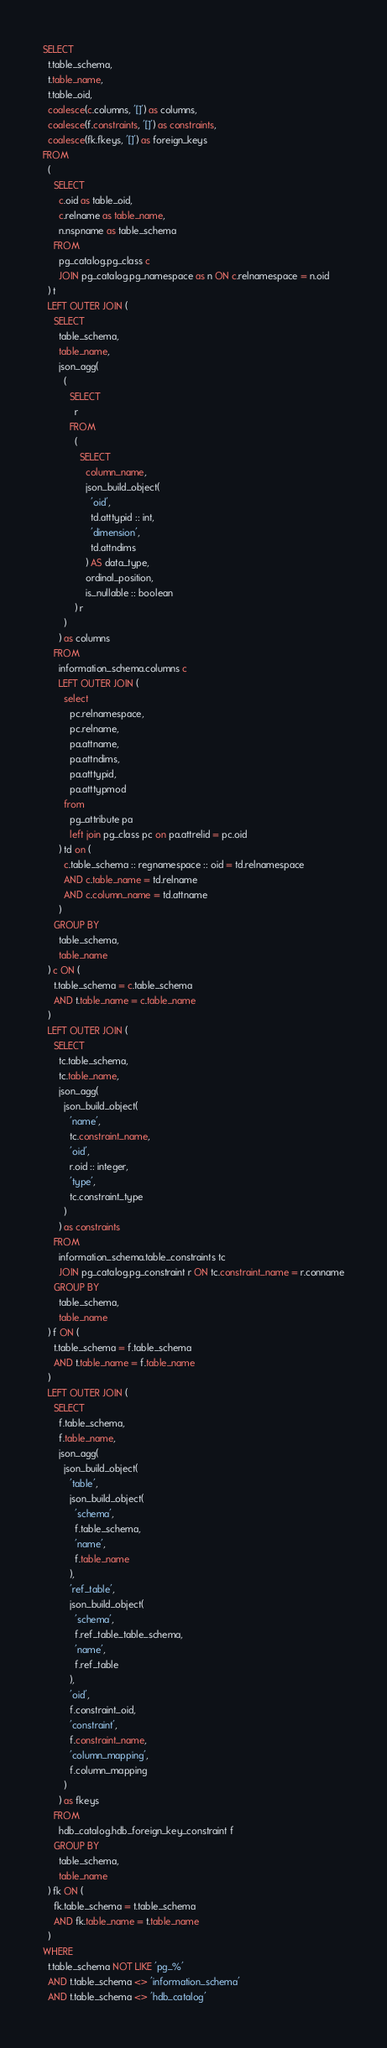<code> <loc_0><loc_0><loc_500><loc_500><_SQL_>SELECT
  t.table_schema,
  t.table_name,
  t.table_oid,
  coalesce(c.columns, '[]') as columns,
  coalesce(f.constraints, '[]') as constraints,
  coalesce(fk.fkeys, '[]') as foreign_keys
FROM
  (
    SELECT
      c.oid as table_oid,
      c.relname as table_name,
      n.nspname as table_schema
    FROM
      pg_catalog.pg_class c
      JOIN pg_catalog.pg_namespace as n ON c.relnamespace = n.oid
  ) t
  LEFT OUTER JOIN (
    SELECT
      table_schema,
      table_name,
      json_agg(
        (
          SELECT
            r
          FROM
            (
              SELECT
                column_name,
                json_build_object(
                  'oid',
                  td.atttypid :: int,
                  'dimension',
                  td.attndims
                ) AS data_type,
                ordinal_position,
                is_nullable :: boolean
            ) r
        )
      ) as columns
    FROM
      information_schema.columns c
      LEFT OUTER JOIN (
        select
          pc.relnamespace,
          pc.relname,
          pa.attname,
          pa.attndims,
          pa.atttypid,
          pa.atttypmod
        from
          pg_attribute pa
          left join pg_class pc on pa.attrelid = pc.oid
      ) td on (
        c.table_schema :: regnamespace :: oid = td.relnamespace
        AND c.table_name = td.relname
        AND c.column_name = td.attname
      )
    GROUP BY
      table_schema,
      table_name
  ) c ON (
    t.table_schema = c.table_schema
    AND t.table_name = c.table_name
  )
  LEFT OUTER JOIN (
    SELECT
      tc.table_schema,
      tc.table_name,
      json_agg(
        json_build_object(
          'name',
          tc.constraint_name,
          'oid',
          r.oid :: integer,
          'type',
          tc.constraint_type
        )
      ) as constraints
    FROM
      information_schema.table_constraints tc
      JOIN pg_catalog.pg_constraint r ON tc.constraint_name = r.conname
    GROUP BY
      table_schema,
      table_name
  ) f ON (
    t.table_schema = f.table_schema
    AND t.table_name = f.table_name
  )
  LEFT OUTER JOIN (
    SELECT
      f.table_schema,
      f.table_name,
      json_agg(
        json_build_object(
          'table',
          json_build_object(
            'schema',
            f.table_schema,
            'name',
            f.table_name
          ),
          'ref_table',
          json_build_object(
            'schema',
            f.ref_table_table_schema,
            'name',
            f.ref_table
          ),
          'oid',
          f.constraint_oid,
          'constraint',
          f.constraint_name,
          'column_mapping',
          f.column_mapping
        )
      ) as fkeys
    FROM
      hdb_catalog.hdb_foreign_key_constraint f
    GROUP BY
      table_schema,
      table_name
  ) fk ON (
    fk.table_schema = t.table_schema
    AND fk.table_name = t.table_name
  )
WHERE
  t.table_schema NOT LIKE 'pg_%'
  AND t.table_schema <> 'information_schema'
  AND t.table_schema <> 'hdb_catalog'
</code> 